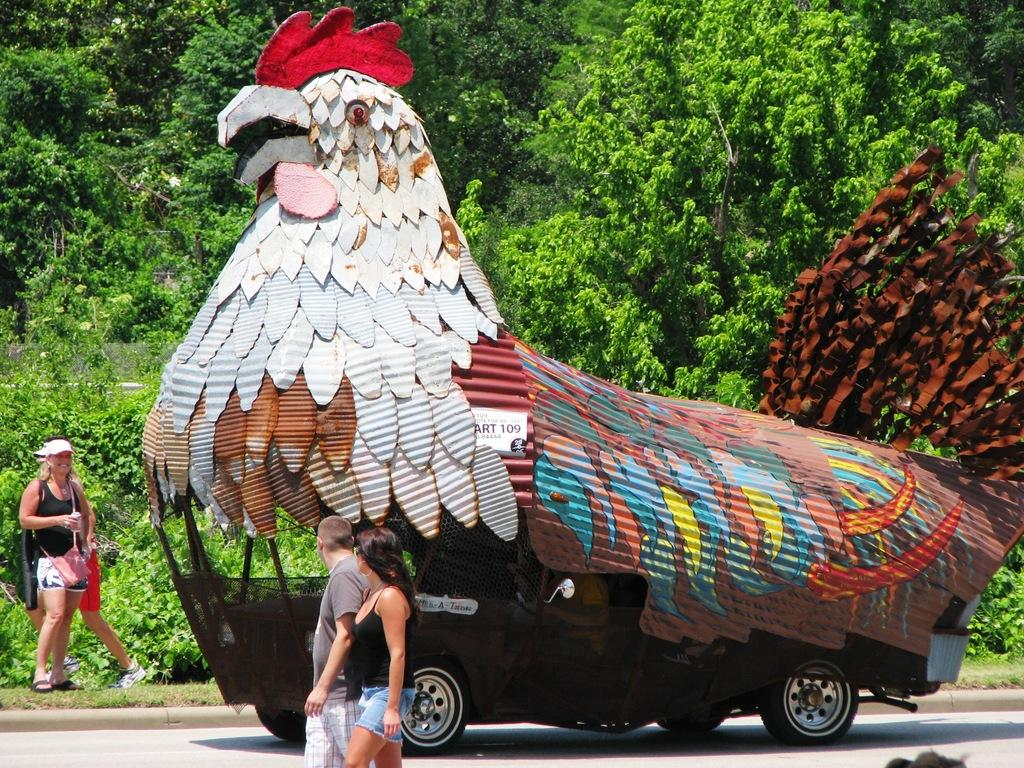What type of vehicle is depicted in the image? There is a vehicle in the shape of a hen in the image. What can be seen on the left side of the image? There are people with different color dresses on the left side of the image. What is visible in the background of the image? There are many trees in the background of the image. How much money is being exchanged between the people in the image? There is no indication of money being exchanged in the image. What word is being spoken by the people in the image? There is no specific word being spoken by the people in the image; we can only see their different color dresses. 